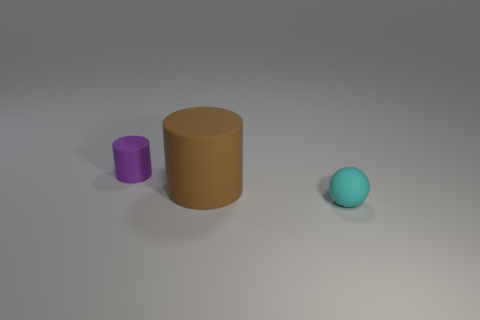There is a cyan rubber object that is the same size as the purple rubber cylinder; what shape is it?
Keep it short and to the point. Sphere. What number of matte things are to the right of the small matte cylinder left of the brown cylinder?
Your answer should be very brief. 2. How many other things are the same material as the small cyan object?
Make the answer very short. 2. What shape is the small matte thing that is in front of the small rubber thing that is behind the ball?
Offer a terse response. Sphere. What size is the matte cylinder that is on the left side of the big cylinder?
Your answer should be very brief. Small. Is the tiny cylinder made of the same material as the cyan sphere?
Your response must be concise. Yes. There is a big brown object that is made of the same material as the cyan ball; what is its shape?
Ensure brevity in your answer.  Cylinder. What is the color of the tiny matte object that is in front of the purple cylinder?
Your answer should be very brief. Cyan. How many purple matte things have the same size as the cyan matte sphere?
Give a very brief answer. 1. What is the shape of the brown thing?
Provide a short and direct response. Cylinder. 